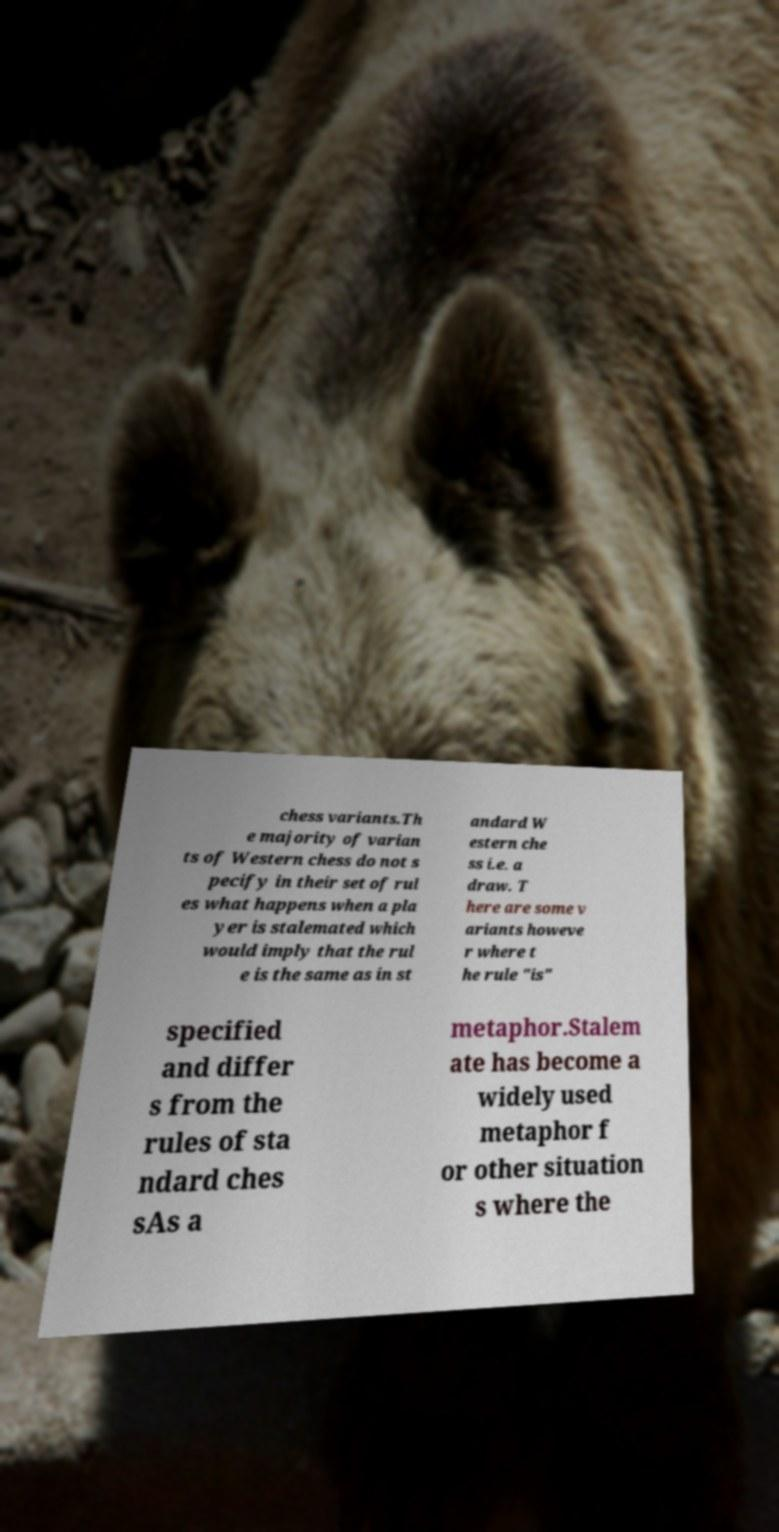What messages or text are displayed in this image? I need them in a readable, typed format. chess variants.Th e majority of varian ts of Western chess do not s pecify in their set of rul es what happens when a pla yer is stalemated which would imply that the rul e is the same as in st andard W estern che ss i.e. a draw. T here are some v ariants howeve r where t he rule "is" specified and differ s from the rules of sta ndard ches sAs a metaphor.Stalem ate has become a widely used metaphor f or other situation s where the 